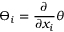Convert formula to latex. <formula><loc_0><loc_0><loc_500><loc_500>\varTheta _ { i } = \frac { \partial } { \partial x _ { i } } \theta</formula> 